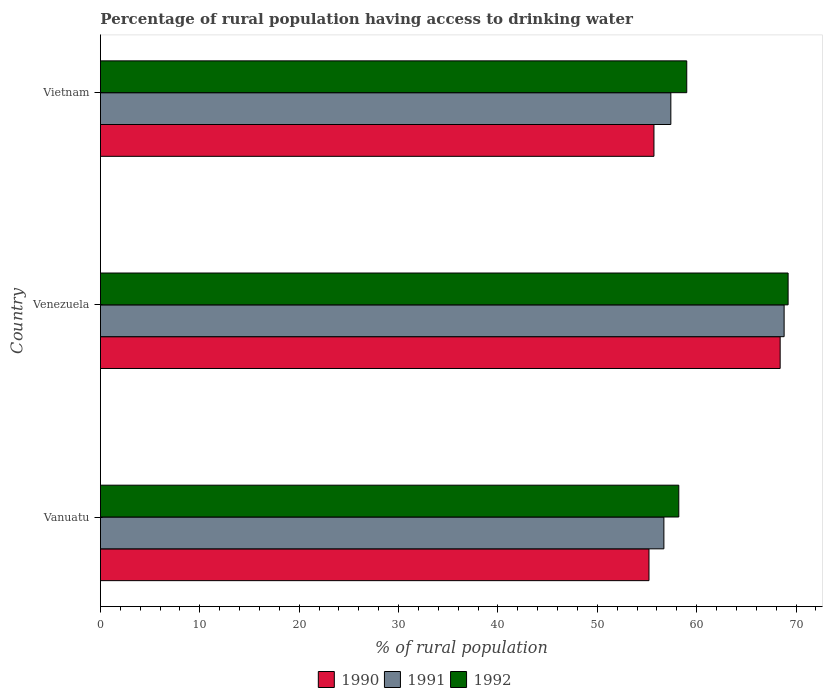How many bars are there on the 2nd tick from the top?
Make the answer very short. 3. How many bars are there on the 3rd tick from the bottom?
Your response must be concise. 3. What is the label of the 1st group of bars from the top?
Provide a succinct answer. Vietnam. What is the percentage of rural population having access to drinking water in 1991 in Vanuatu?
Give a very brief answer. 56.7. Across all countries, what is the maximum percentage of rural population having access to drinking water in 1990?
Your response must be concise. 68.4. Across all countries, what is the minimum percentage of rural population having access to drinking water in 1990?
Your response must be concise. 55.2. In which country was the percentage of rural population having access to drinking water in 1992 maximum?
Ensure brevity in your answer.  Venezuela. In which country was the percentage of rural population having access to drinking water in 1991 minimum?
Your response must be concise. Vanuatu. What is the total percentage of rural population having access to drinking water in 1990 in the graph?
Make the answer very short. 179.3. What is the difference between the percentage of rural population having access to drinking water in 1991 in Vanuatu and that in Vietnam?
Ensure brevity in your answer.  -0.7. What is the difference between the percentage of rural population having access to drinking water in 1990 in Venezuela and the percentage of rural population having access to drinking water in 1991 in Vanuatu?
Offer a terse response. 11.7. What is the average percentage of rural population having access to drinking water in 1990 per country?
Your response must be concise. 59.77. What is the difference between the percentage of rural population having access to drinking water in 1991 and percentage of rural population having access to drinking water in 1990 in Venezuela?
Give a very brief answer. 0.4. What is the ratio of the percentage of rural population having access to drinking water in 1990 in Venezuela to that in Vietnam?
Ensure brevity in your answer.  1.23. What is the difference between the highest and the second highest percentage of rural population having access to drinking water in 1990?
Your answer should be compact. 12.7. What is the difference between the highest and the lowest percentage of rural population having access to drinking water in 1991?
Your response must be concise. 12.1. In how many countries, is the percentage of rural population having access to drinking water in 1991 greater than the average percentage of rural population having access to drinking water in 1991 taken over all countries?
Keep it short and to the point. 1. Is it the case that in every country, the sum of the percentage of rural population having access to drinking water in 1990 and percentage of rural population having access to drinking water in 1992 is greater than the percentage of rural population having access to drinking water in 1991?
Provide a succinct answer. Yes. How many countries are there in the graph?
Make the answer very short. 3. What is the difference between two consecutive major ticks on the X-axis?
Keep it short and to the point. 10. How many legend labels are there?
Provide a short and direct response. 3. How are the legend labels stacked?
Your response must be concise. Horizontal. What is the title of the graph?
Make the answer very short. Percentage of rural population having access to drinking water. What is the label or title of the X-axis?
Offer a terse response. % of rural population. What is the label or title of the Y-axis?
Offer a very short reply. Country. What is the % of rural population in 1990 in Vanuatu?
Provide a short and direct response. 55.2. What is the % of rural population in 1991 in Vanuatu?
Provide a succinct answer. 56.7. What is the % of rural population in 1992 in Vanuatu?
Your answer should be compact. 58.2. What is the % of rural population of 1990 in Venezuela?
Keep it short and to the point. 68.4. What is the % of rural population of 1991 in Venezuela?
Ensure brevity in your answer.  68.8. What is the % of rural population in 1992 in Venezuela?
Make the answer very short. 69.2. What is the % of rural population in 1990 in Vietnam?
Keep it short and to the point. 55.7. What is the % of rural population of 1991 in Vietnam?
Your answer should be compact. 57.4. What is the % of rural population of 1992 in Vietnam?
Offer a terse response. 59. Across all countries, what is the maximum % of rural population of 1990?
Keep it short and to the point. 68.4. Across all countries, what is the maximum % of rural population of 1991?
Offer a very short reply. 68.8. Across all countries, what is the maximum % of rural population of 1992?
Keep it short and to the point. 69.2. Across all countries, what is the minimum % of rural population of 1990?
Ensure brevity in your answer.  55.2. Across all countries, what is the minimum % of rural population of 1991?
Give a very brief answer. 56.7. Across all countries, what is the minimum % of rural population of 1992?
Provide a short and direct response. 58.2. What is the total % of rural population in 1990 in the graph?
Ensure brevity in your answer.  179.3. What is the total % of rural population of 1991 in the graph?
Offer a very short reply. 182.9. What is the total % of rural population of 1992 in the graph?
Your answer should be very brief. 186.4. What is the difference between the % of rural population of 1990 in Vanuatu and that in Venezuela?
Keep it short and to the point. -13.2. What is the difference between the % of rural population of 1991 in Venezuela and that in Vietnam?
Offer a terse response. 11.4. What is the difference between the % of rural population in 1992 in Venezuela and that in Vietnam?
Your response must be concise. 10.2. What is the difference between the % of rural population in 1990 in Vanuatu and the % of rural population in 1991 in Venezuela?
Keep it short and to the point. -13.6. What is the difference between the % of rural population in 1990 in Vanuatu and the % of rural population in 1992 in Venezuela?
Provide a succinct answer. -14. What is the difference between the % of rural population of 1991 in Vanuatu and the % of rural population of 1992 in Venezuela?
Your answer should be very brief. -12.5. What is the difference between the % of rural population in 1991 in Vanuatu and the % of rural population in 1992 in Vietnam?
Give a very brief answer. -2.3. What is the difference between the % of rural population of 1990 in Venezuela and the % of rural population of 1991 in Vietnam?
Ensure brevity in your answer.  11. What is the difference between the % of rural population of 1990 in Venezuela and the % of rural population of 1992 in Vietnam?
Give a very brief answer. 9.4. What is the difference between the % of rural population in 1991 in Venezuela and the % of rural population in 1992 in Vietnam?
Provide a succinct answer. 9.8. What is the average % of rural population of 1990 per country?
Ensure brevity in your answer.  59.77. What is the average % of rural population in 1991 per country?
Offer a terse response. 60.97. What is the average % of rural population in 1992 per country?
Your answer should be compact. 62.13. What is the difference between the % of rural population of 1990 and % of rural population of 1991 in Vanuatu?
Offer a terse response. -1.5. What is the difference between the % of rural population of 1990 and % of rural population of 1992 in Vanuatu?
Your answer should be compact. -3. What is the difference between the % of rural population in 1990 and % of rural population in 1991 in Venezuela?
Your response must be concise. -0.4. What is the difference between the % of rural population of 1990 and % of rural population of 1992 in Venezuela?
Your answer should be very brief. -0.8. What is the difference between the % of rural population in 1990 and % of rural population in 1992 in Vietnam?
Offer a very short reply. -3.3. What is the difference between the % of rural population of 1991 and % of rural population of 1992 in Vietnam?
Provide a succinct answer. -1.6. What is the ratio of the % of rural population of 1990 in Vanuatu to that in Venezuela?
Provide a short and direct response. 0.81. What is the ratio of the % of rural population of 1991 in Vanuatu to that in Venezuela?
Your answer should be very brief. 0.82. What is the ratio of the % of rural population of 1992 in Vanuatu to that in Venezuela?
Offer a very short reply. 0.84. What is the ratio of the % of rural population of 1991 in Vanuatu to that in Vietnam?
Give a very brief answer. 0.99. What is the ratio of the % of rural population in 1992 in Vanuatu to that in Vietnam?
Your response must be concise. 0.99. What is the ratio of the % of rural population of 1990 in Venezuela to that in Vietnam?
Provide a short and direct response. 1.23. What is the ratio of the % of rural population in 1991 in Venezuela to that in Vietnam?
Your answer should be compact. 1.2. What is the ratio of the % of rural population in 1992 in Venezuela to that in Vietnam?
Offer a terse response. 1.17. What is the difference between the highest and the second highest % of rural population of 1990?
Your response must be concise. 12.7. What is the difference between the highest and the lowest % of rural population of 1990?
Give a very brief answer. 13.2. What is the difference between the highest and the lowest % of rural population in 1991?
Ensure brevity in your answer.  12.1. What is the difference between the highest and the lowest % of rural population of 1992?
Make the answer very short. 11. 